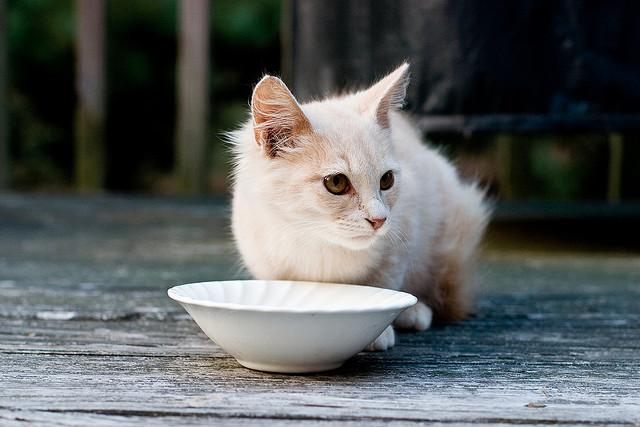What is the cat drinking?
Write a very short answer. Milk. Is the kitty thirsty?
Be succinct. No. What is the kitty laying on?
Quick response, please. Porch. What is the kitty doing?
Give a very brief answer. Eating. 